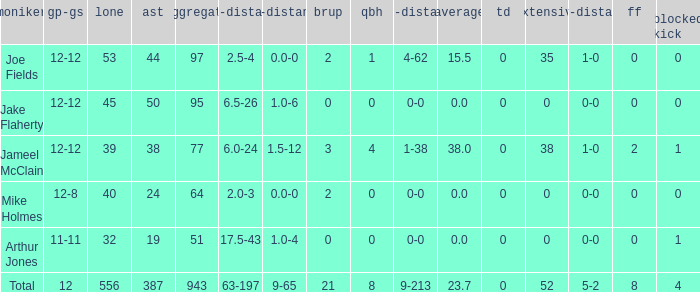How many players named jake flaherty? 1.0. 